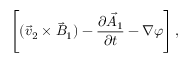Convert formula to latex. <formula><loc_0><loc_0><loc_500><loc_500>\left [ ( \vec { v } _ { 2 } \times \vec { B } _ { 1 } ) - \frac { \partial \vec { A } _ { 1 } } { \partial t } - \nabla \varphi \right ] ,</formula> 